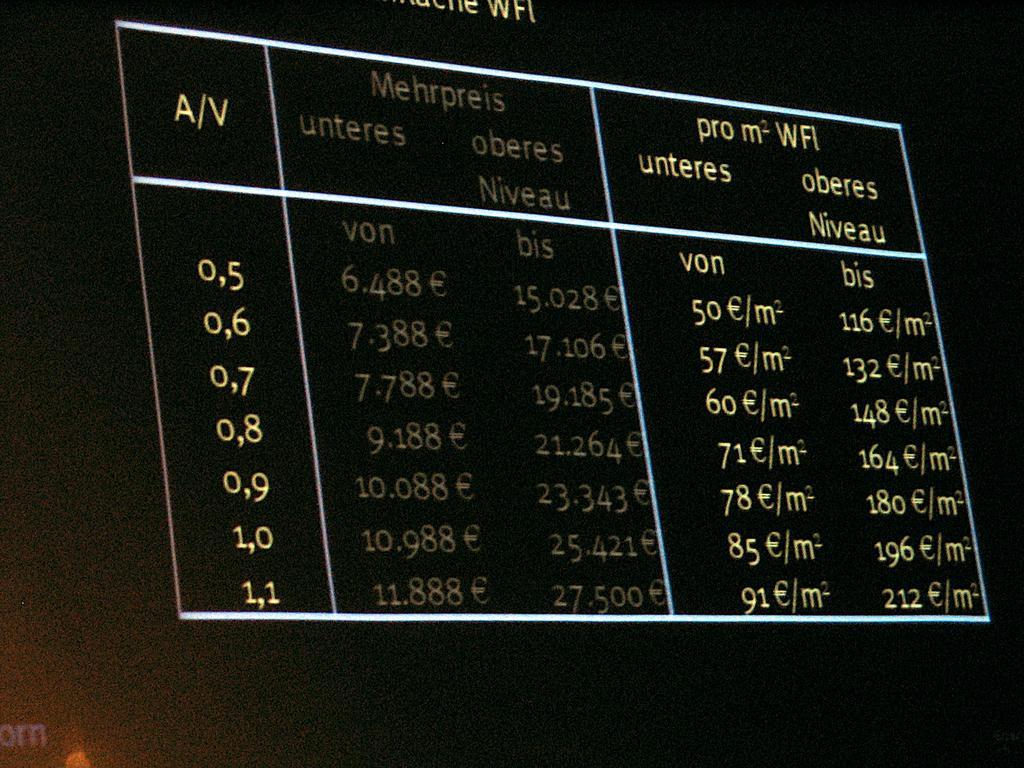Describe this image in one or two sentences. In this image we can see an object, which looks like a board, on the board we can see some text. 